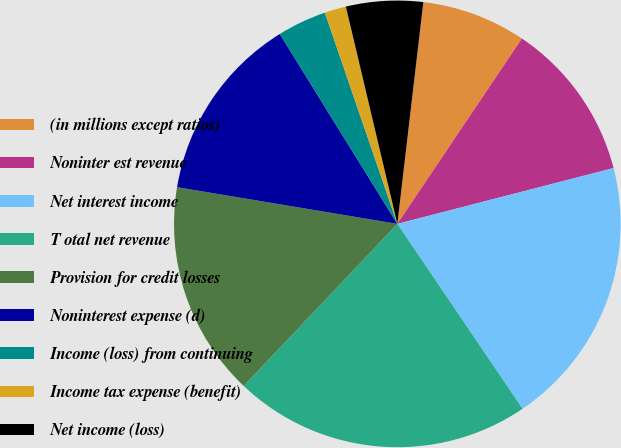<chart> <loc_0><loc_0><loc_500><loc_500><pie_chart><fcel>(in millions except ratios)<fcel>Noninter est revenue<fcel>Net interest income<fcel>T otal net revenue<fcel>Provision for credit losses<fcel>Noninterest expense (d)<fcel>Income (loss) from continuing<fcel>Income tax expense (benefit)<fcel>Net income (loss)<nl><fcel>7.56%<fcel>11.56%<fcel>19.55%<fcel>21.55%<fcel>15.55%<fcel>13.55%<fcel>3.56%<fcel>1.56%<fcel>5.56%<nl></chart> 